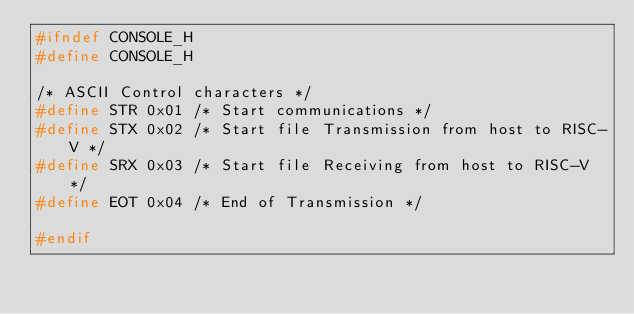<code> <loc_0><loc_0><loc_500><loc_500><_C_>#ifndef CONSOLE_H
#define CONSOLE_H

/* ASCII Control characters */
#define STR 0x01 /* Start communications */
#define STX 0x02 /* Start file Transmission from host to RISC-V */
#define SRX 0x03 /* Start file Receiving from host to RISC-V */
#define EOT 0x04 /* End of Transmission */

#endif
</code> 